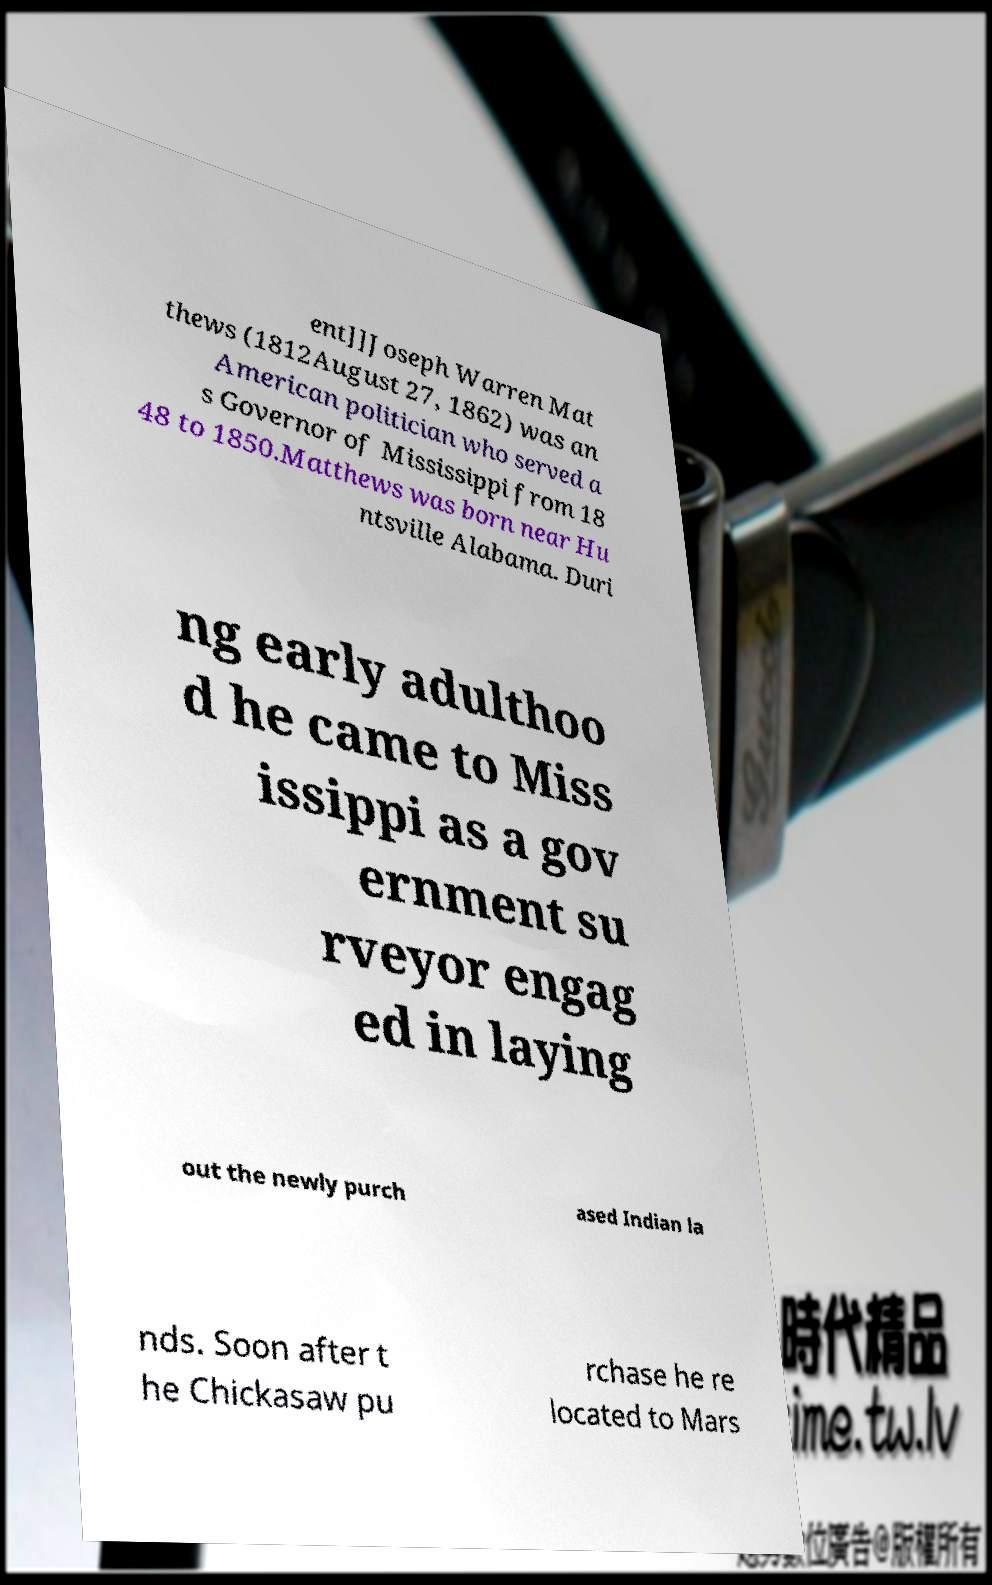There's text embedded in this image that I need extracted. Can you transcribe it verbatim? ent]]Joseph Warren Mat thews (1812August 27, 1862) was an American politician who served a s Governor of Mississippi from 18 48 to 1850.Matthews was born near Hu ntsville Alabama. Duri ng early adulthoo d he came to Miss issippi as a gov ernment su rveyor engag ed in laying out the newly purch ased Indian la nds. Soon after t he Chickasaw pu rchase he re located to Mars 